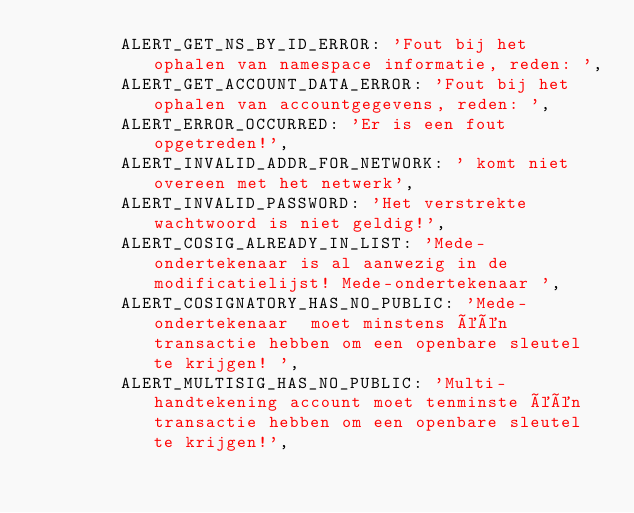Convert code to text. <code><loc_0><loc_0><loc_500><loc_500><_JavaScript_>        ALERT_GET_NS_BY_ID_ERROR: 'Fout bij het ophalen van namespace informatie, reden: ',
        ALERT_GET_ACCOUNT_DATA_ERROR: 'Fout bij het ophalen van accountgegevens, reden: ',
        ALERT_ERROR_OCCURRED: 'Er is een fout opgetreden!',
        ALERT_INVALID_ADDR_FOR_NETWORK: ' komt niet overeen met het netwerk',
        ALERT_INVALID_PASSWORD: 'Het verstrekte wachtwoord is niet geldig!',
        ALERT_COSIG_ALREADY_IN_LIST: 'Mede-ondertekenaar is al aanwezig in de modificatielijst! Mede-ondertekenaar ',
        ALERT_COSIGNATORY_HAS_NO_PUBLIC: 'Mede-ondertekenaar  moet minstens één transactie hebben om een openbare sleutel te krijgen! ',
        ALERT_MULTISIG_HAS_NO_PUBLIC: 'Multi-handtekening account moet tenminste één transactie hebben om een openbare sleutel te krijgen!',</code> 